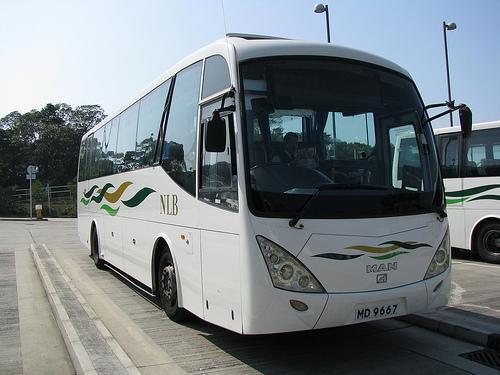How many buses do you see?
Give a very brief answer. 2. How many parking lot lights are there?
Give a very brief answer. 2. 